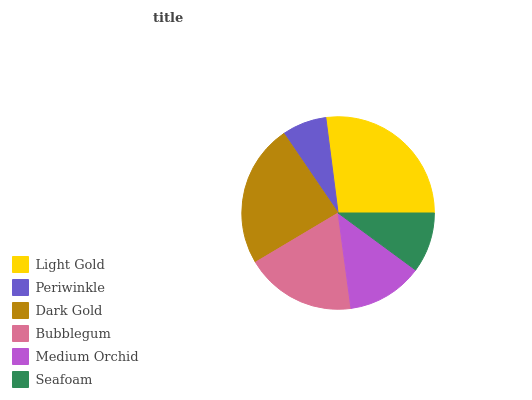Is Periwinkle the minimum?
Answer yes or no. Yes. Is Light Gold the maximum?
Answer yes or no. Yes. Is Dark Gold the minimum?
Answer yes or no. No. Is Dark Gold the maximum?
Answer yes or no. No. Is Dark Gold greater than Periwinkle?
Answer yes or no. Yes. Is Periwinkle less than Dark Gold?
Answer yes or no. Yes. Is Periwinkle greater than Dark Gold?
Answer yes or no. No. Is Dark Gold less than Periwinkle?
Answer yes or no. No. Is Bubblegum the high median?
Answer yes or no. Yes. Is Medium Orchid the low median?
Answer yes or no. Yes. Is Dark Gold the high median?
Answer yes or no. No. Is Seafoam the low median?
Answer yes or no. No. 